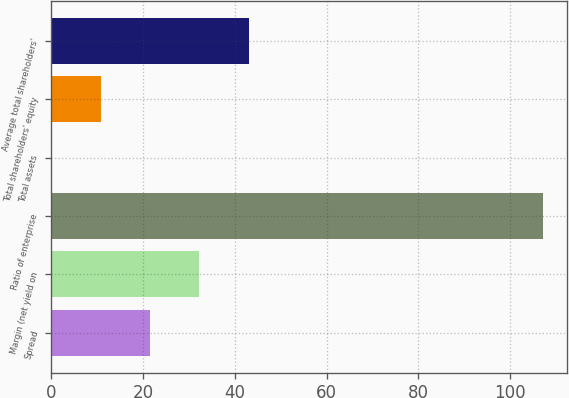Convert chart. <chart><loc_0><loc_0><loc_500><loc_500><bar_chart><fcel>Spread<fcel>Margin (net yield on<fcel>Ratio of enterprise<fcel>Total assets<fcel>Total shareholders' equity<fcel>Average total shareholders'<nl><fcel>21.59<fcel>32.29<fcel>107.18<fcel>0.19<fcel>10.89<fcel>42.99<nl></chart> 